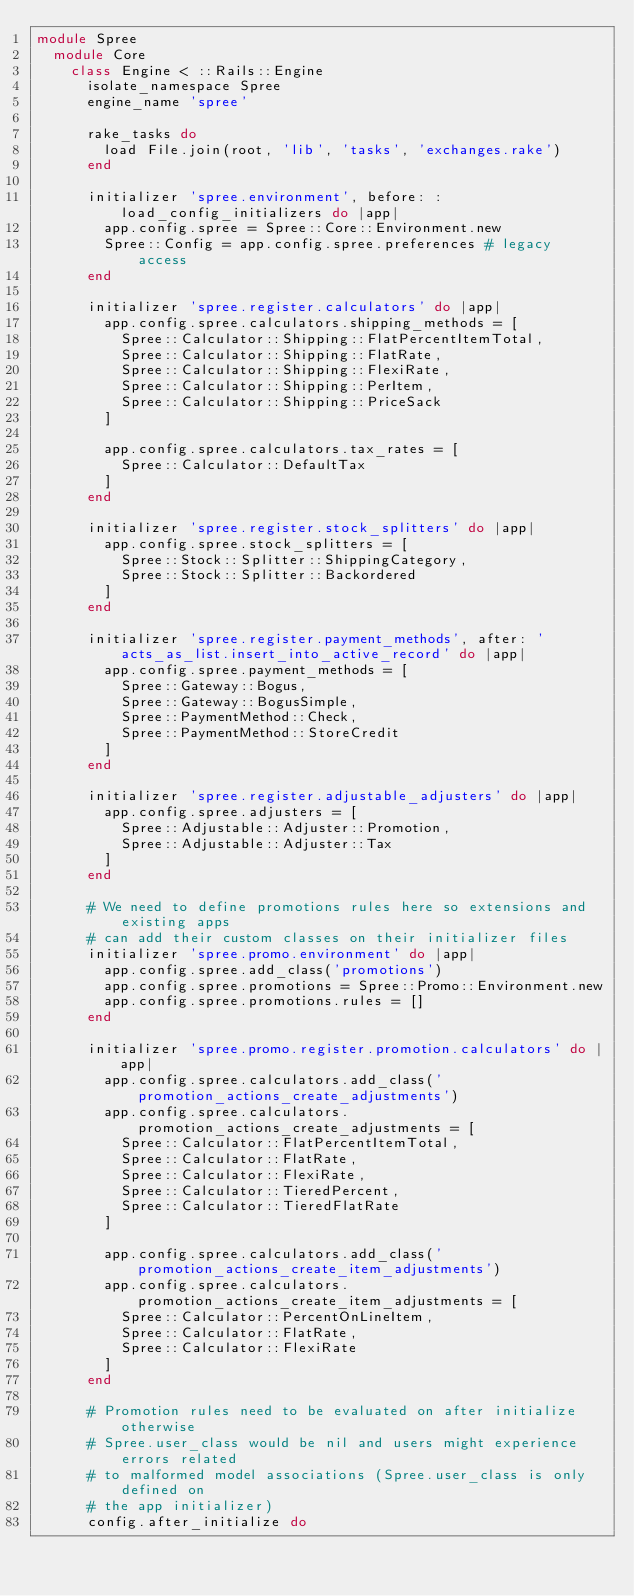Convert code to text. <code><loc_0><loc_0><loc_500><loc_500><_Ruby_>module Spree
  module Core
    class Engine < ::Rails::Engine
      isolate_namespace Spree
      engine_name 'spree'

      rake_tasks do
        load File.join(root, 'lib', 'tasks', 'exchanges.rake')
      end

      initializer 'spree.environment', before: :load_config_initializers do |app|
        app.config.spree = Spree::Core::Environment.new
        Spree::Config = app.config.spree.preferences # legacy access
      end

      initializer 'spree.register.calculators' do |app|
        app.config.spree.calculators.shipping_methods = [
          Spree::Calculator::Shipping::FlatPercentItemTotal,
          Spree::Calculator::Shipping::FlatRate,
          Spree::Calculator::Shipping::FlexiRate,
          Spree::Calculator::Shipping::PerItem,
          Spree::Calculator::Shipping::PriceSack
        ]

        app.config.spree.calculators.tax_rates = [
          Spree::Calculator::DefaultTax
        ]
      end

      initializer 'spree.register.stock_splitters' do |app|
        app.config.spree.stock_splitters = [
          Spree::Stock::Splitter::ShippingCategory,
          Spree::Stock::Splitter::Backordered
        ]
      end

      initializer 'spree.register.payment_methods', after: 'acts_as_list.insert_into_active_record' do |app|
        app.config.spree.payment_methods = [
          Spree::Gateway::Bogus,
          Spree::Gateway::BogusSimple,
          Spree::PaymentMethod::Check,
          Spree::PaymentMethod::StoreCredit
        ]
      end

      initializer 'spree.register.adjustable_adjusters' do |app|
        app.config.spree.adjusters = [
          Spree::Adjustable::Adjuster::Promotion,
          Spree::Adjustable::Adjuster::Tax
        ]
      end

      # We need to define promotions rules here so extensions and existing apps
      # can add their custom classes on their initializer files
      initializer 'spree.promo.environment' do |app|
        app.config.spree.add_class('promotions')
        app.config.spree.promotions = Spree::Promo::Environment.new
        app.config.spree.promotions.rules = []
      end

      initializer 'spree.promo.register.promotion.calculators' do |app|
        app.config.spree.calculators.add_class('promotion_actions_create_adjustments')
        app.config.spree.calculators.promotion_actions_create_adjustments = [
          Spree::Calculator::FlatPercentItemTotal,
          Spree::Calculator::FlatRate,
          Spree::Calculator::FlexiRate,
          Spree::Calculator::TieredPercent,
          Spree::Calculator::TieredFlatRate
        ]

        app.config.spree.calculators.add_class('promotion_actions_create_item_adjustments')
        app.config.spree.calculators.promotion_actions_create_item_adjustments = [
          Spree::Calculator::PercentOnLineItem,
          Spree::Calculator::FlatRate,
          Spree::Calculator::FlexiRate
        ]
      end

      # Promotion rules need to be evaluated on after initialize otherwise
      # Spree.user_class would be nil and users might experience errors related
      # to malformed model associations (Spree.user_class is only defined on
      # the app initializer)
      config.after_initialize do</code> 